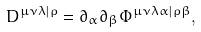<formula> <loc_0><loc_0><loc_500><loc_500>D ^ { \mu \nu \lambda | \rho } = \partial _ { \alpha } \partial _ { \beta } \Phi ^ { \mu \nu \lambda \alpha | \rho \beta } ,</formula> 